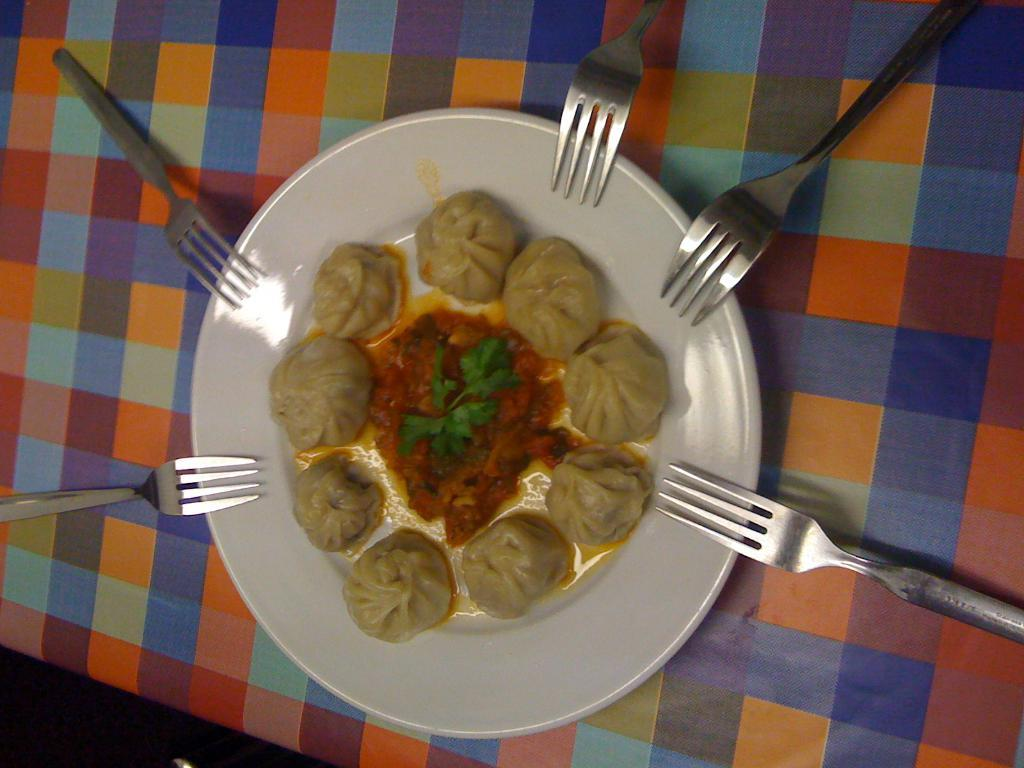What type of food is visible in the image? There are momos in the image. Are there any other food items present besides momos? Yes, there are other food items in the image. How are the food items arranged in the image? The food items are on a plate in the image. What utensils can be seen on the table in the image? There are forks on the table in the image. What type of chair is visible in the image? There is no chair present in the image. Can you tell me how many volleyballs are on the table in the image? There are no volleyballs present in the image. 